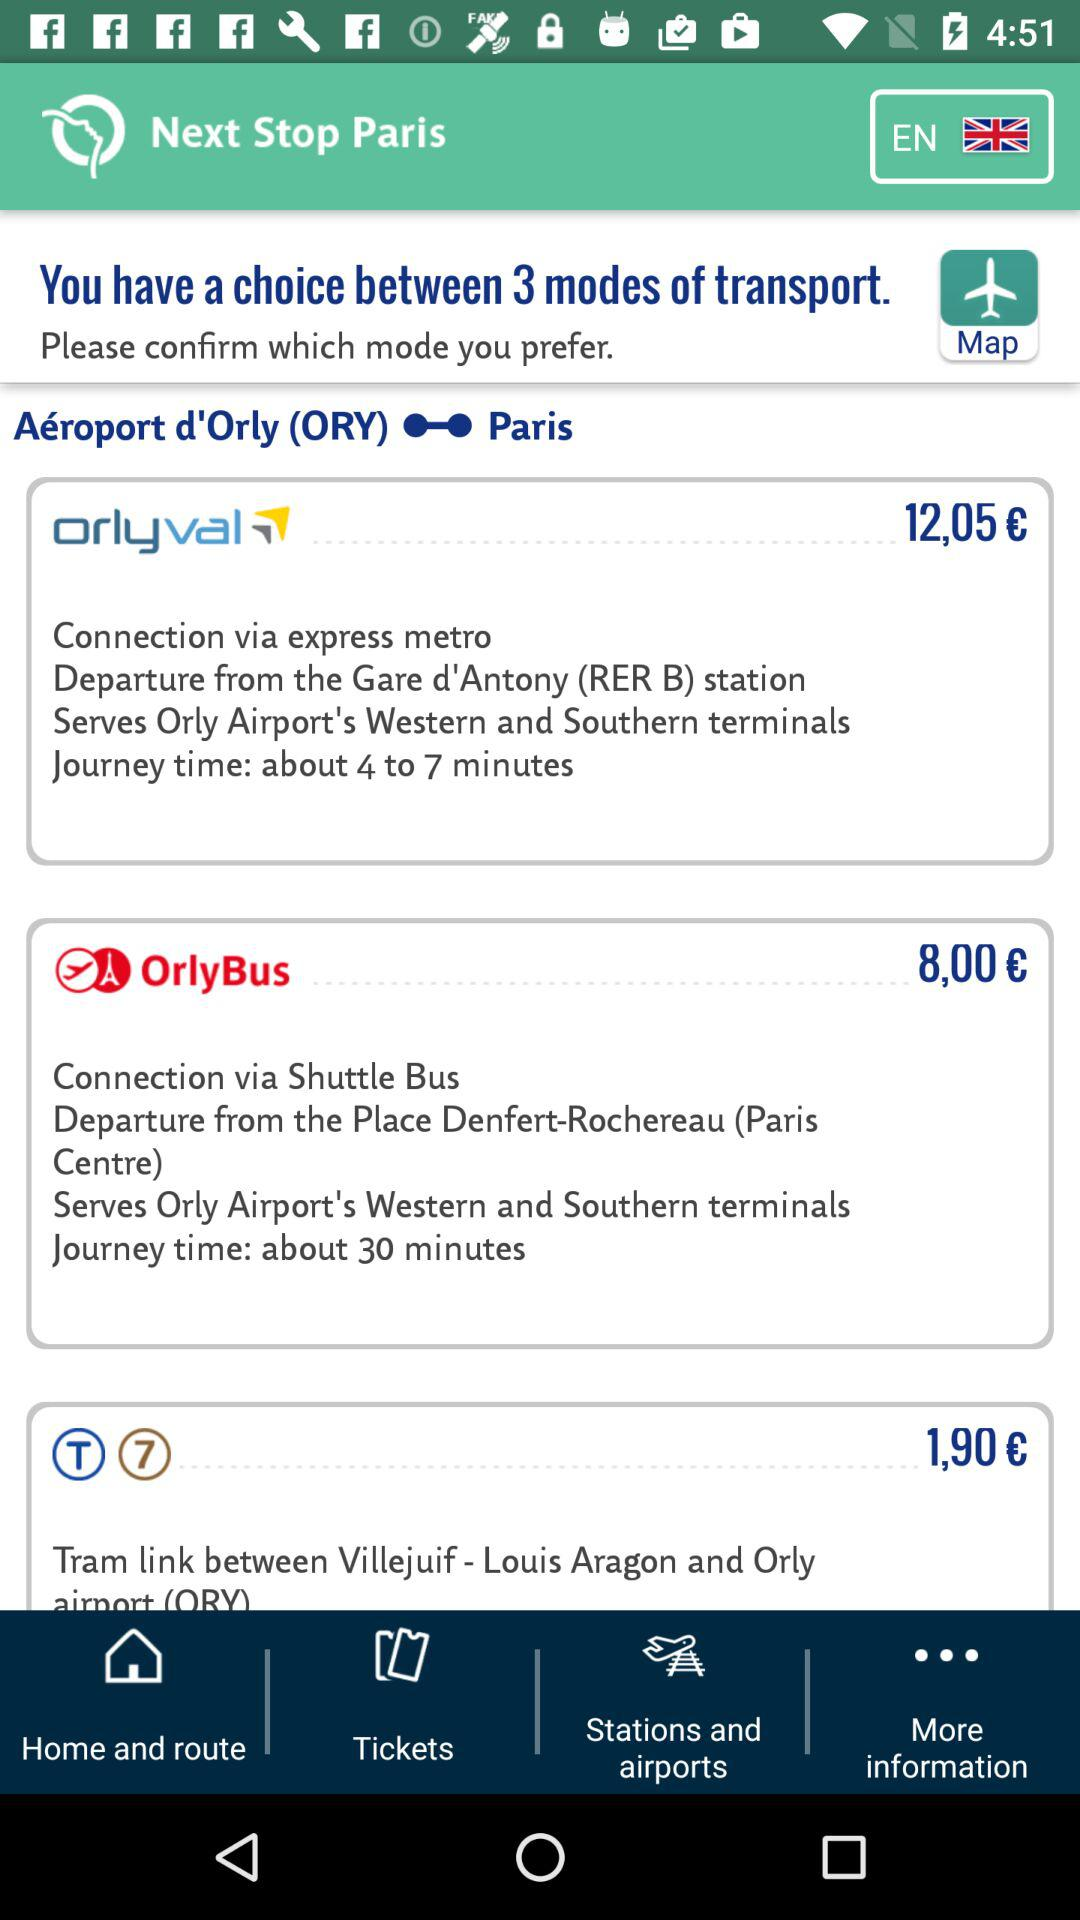What locations are served by Orlyval? Orlyval serves Orly Airport's Western and Southern terminals. 